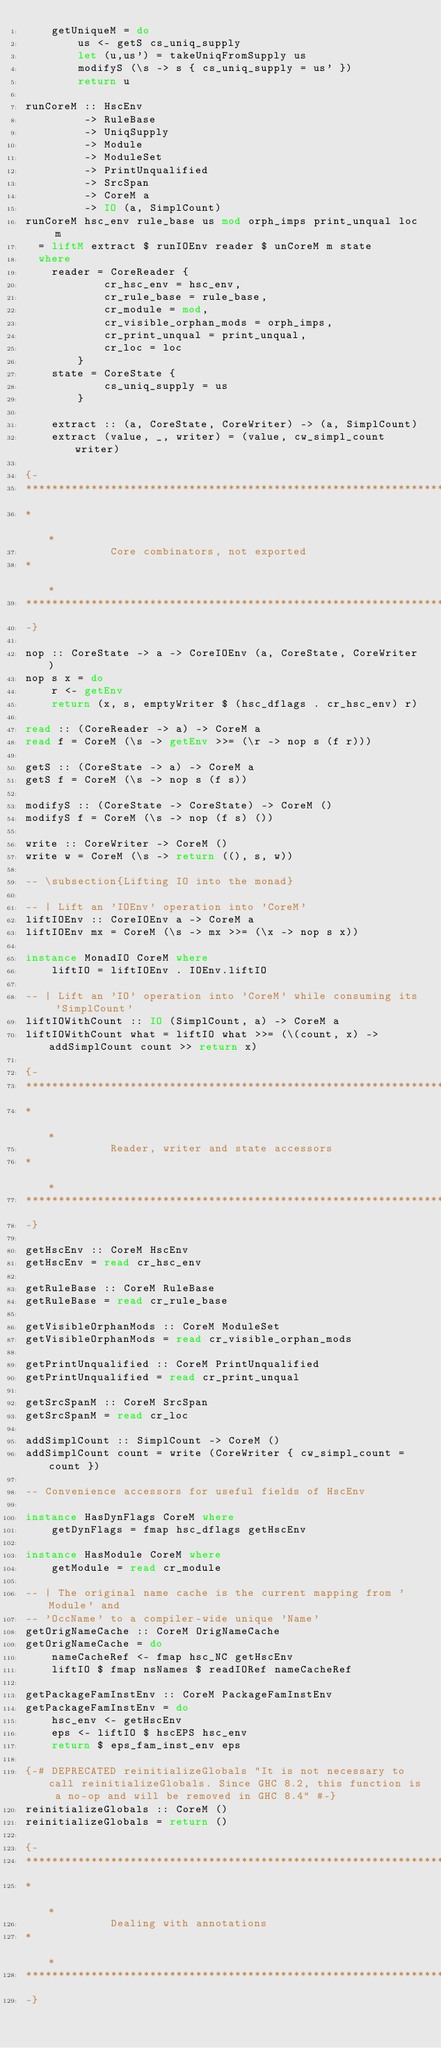<code> <loc_0><loc_0><loc_500><loc_500><_Haskell_>    getUniqueM = do
        us <- getS cs_uniq_supply
        let (u,us') = takeUniqFromSupply us
        modifyS (\s -> s { cs_uniq_supply = us' })
        return u

runCoreM :: HscEnv
         -> RuleBase
         -> UniqSupply
         -> Module
         -> ModuleSet
         -> PrintUnqualified
         -> SrcSpan
         -> CoreM a
         -> IO (a, SimplCount)
runCoreM hsc_env rule_base us mod orph_imps print_unqual loc m
  = liftM extract $ runIOEnv reader $ unCoreM m state
  where
    reader = CoreReader {
            cr_hsc_env = hsc_env,
            cr_rule_base = rule_base,
            cr_module = mod,
            cr_visible_orphan_mods = orph_imps,
            cr_print_unqual = print_unqual,
            cr_loc = loc
        }
    state = CoreState {
            cs_uniq_supply = us
        }

    extract :: (a, CoreState, CoreWriter) -> (a, SimplCount)
    extract (value, _, writer) = (value, cw_simpl_count writer)

{-
************************************************************************
*                                                                      *
             Core combinators, not exported
*                                                                      *
************************************************************************
-}

nop :: CoreState -> a -> CoreIOEnv (a, CoreState, CoreWriter)
nop s x = do
    r <- getEnv
    return (x, s, emptyWriter $ (hsc_dflags . cr_hsc_env) r)

read :: (CoreReader -> a) -> CoreM a
read f = CoreM (\s -> getEnv >>= (\r -> nop s (f r)))

getS :: (CoreState -> a) -> CoreM a
getS f = CoreM (\s -> nop s (f s))

modifyS :: (CoreState -> CoreState) -> CoreM ()
modifyS f = CoreM (\s -> nop (f s) ())

write :: CoreWriter -> CoreM ()
write w = CoreM (\s -> return ((), s, w))

-- \subsection{Lifting IO into the monad}

-- | Lift an 'IOEnv' operation into 'CoreM'
liftIOEnv :: CoreIOEnv a -> CoreM a
liftIOEnv mx = CoreM (\s -> mx >>= (\x -> nop s x))

instance MonadIO CoreM where
    liftIO = liftIOEnv . IOEnv.liftIO

-- | Lift an 'IO' operation into 'CoreM' while consuming its 'SimplCount'
liftIOWithCount :: IO (SimplCount, a) -> CoreM a
liftIOWithCount what = liftIO what >>= (\(count, x) -> addSimplCount count >> return x)

{-
************************************************************************
*                                                                      *
             Reader, writer and state accessors
*                                                                      *
************************************************************************
-}

getHscEnv :: CoreM HscEnv
getHscEnv = read cr_hsc_env

getRuleBase :: CoreM RuleBase
getRuleBase = read cr_rule_base

getVisibleOrphanMods :: CoreM ModuleSet
getVisibleOrphanMods = read cr_visible_orphan_mods

getPrintUnqualified :: CoreM PrintUnqualified
getPrintUnqualified = read cr_print_unqual

getSrcSpanM :: CoreM SrcSpan
getSrcSpanM = read cr_loc

addSimplCount :: SimplCount -> CoreM ()
addSimplCount count = write (CoreWriter { cw_simpl_count = count })

-- Convenience accessors for useful fields of HscEnv

instance HasDynFlags CoreM where
    getDynFlags = fmap hsc_dflags getHscEnv

instance HasModule CoreM where
    getModule = read cr_module

-- | The original name cache is the current mapping from 'Module' and
-- 'OccName' to a compiler-wide unique 'Name'
getOrigNameCache :: CoreM OrigNameCache
getOrigNameCache = do
    nameCacheRef <- fmap hsc_NC getHscEnv
    liftIO $ fmap nsNames $ readIORef nameCacheRef

getPackageFamInstEnv :: CoreM PackageFamInstEnv
getPackageFamInstEnv = do
    hsc_env <- getHscEnv
    eps <- liftIO $ hscEPS hsc_env
    return $ eps_fam_inst_env eps

{-# DEPRECATED reinitializeGlobals "It is not necessary to call reinitializeGlobals. Since GHC 8.2, this function is a no-op and will be removed in GHC 8.4" #-}
reinitializeGlobals :: CoreM ()
reinitializeGlobals = return ()

{-
************************************************************************
*                                                                      *
             Dealing with annotations
*                                                                      *
************************************************************************
-}
</code> 